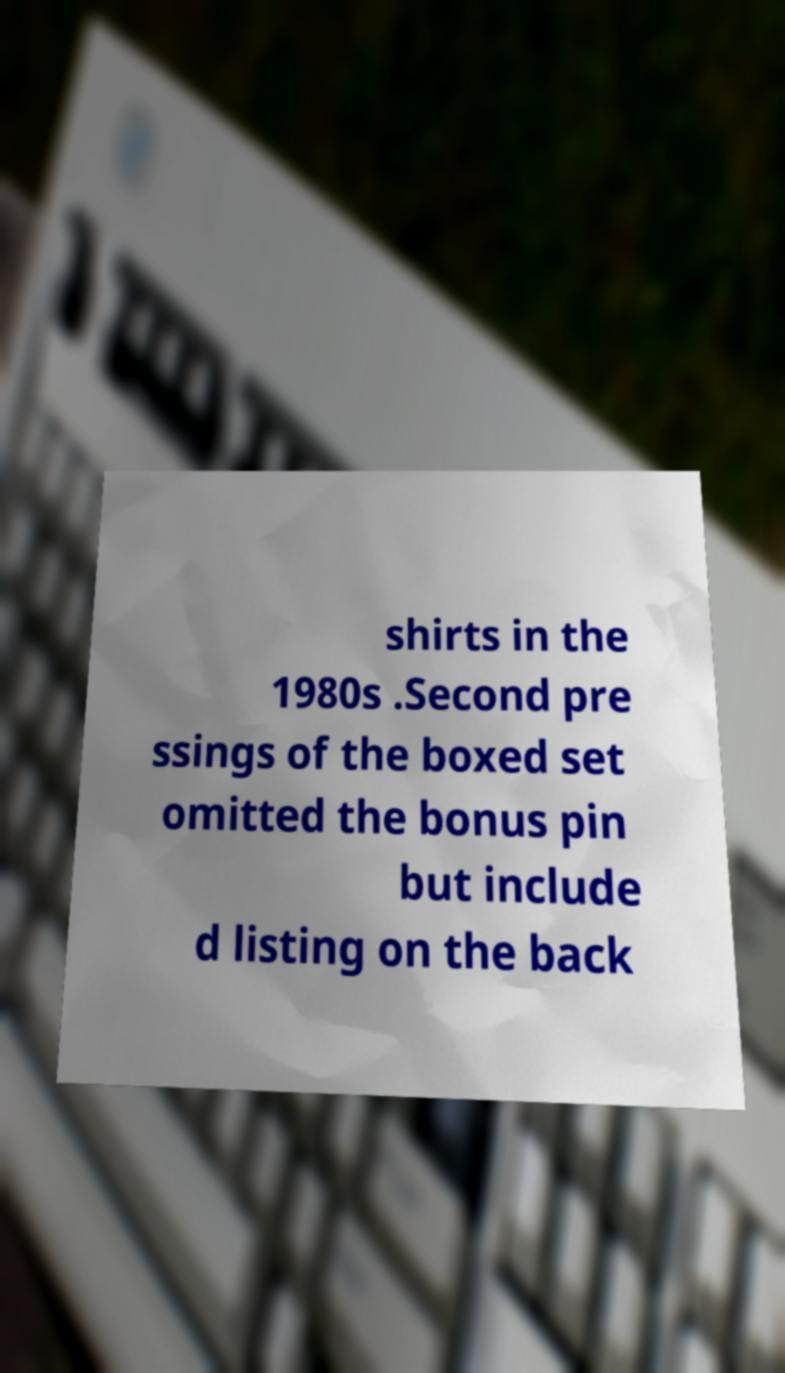Could you assist in decoding the text presented in this image and type it out clearly? shirts in the 1980s .Second pre ssings of the boxed set omitted the bonus pin but include d listing on the back 